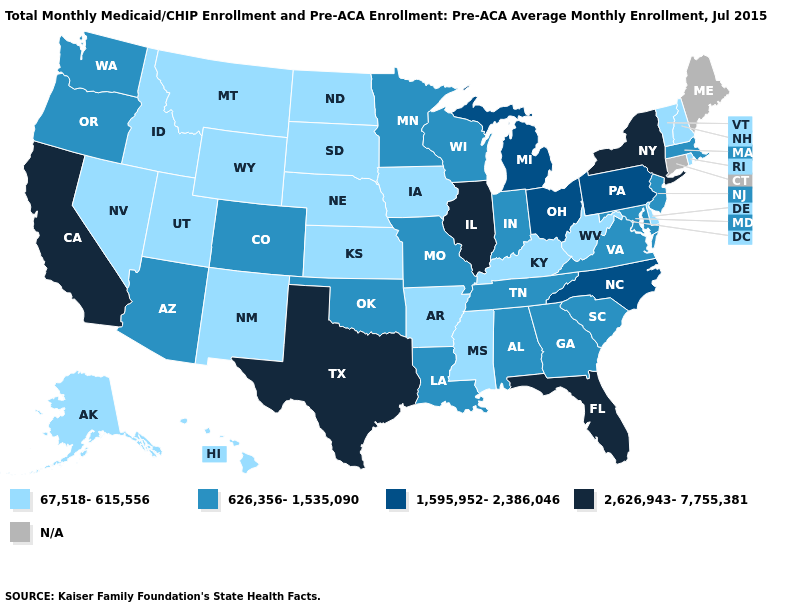Does the map have missing data?
Short answer required. Yes. Among the states that border Virginia , does Maryland have the highest value?
Give a very brief answer. No. What is the value of Michigan?
Write a very short answer. 1,595,952-2,386,046. What is the lowest value in the USA?
Answer briefly. 67,518-615,556. What is the value of Alabama?
Answer briefly. 626,356-1,535,090. Does the map have missing data?
Write a very short answer. Yes. Which states have the lowest value in the USA?
Write a very short answer. Alaska, Arkansas, Delaware, Hawaii, Idaho, Iowa, Kansas, Kentucky, Mississippi, Montana, Nebraska, Nevada, New Hampshire, New Mexico, North Dakota, Rhode Island, South Dakota, Utah, Vermont, West Virginia, Wyoming. What is the value of North Carolina?
Concise answer only. 1,595,952-2,386,046. What is the value of Minnesota?
Short answer required. 626,356-1,535,090. Does Hawaii have the highest value in the West?
Answer briefly. No. What is the value of Minnesota?
Short answer required. 626,356-1,535,090. Among the states that border Massachusetts , which have the lowest value?
Give a very brief answer. New Hampshire, Rhode Island, Vermont. What is the value of Ohio?
Short answer required. 1,595,952-2,386,046. 